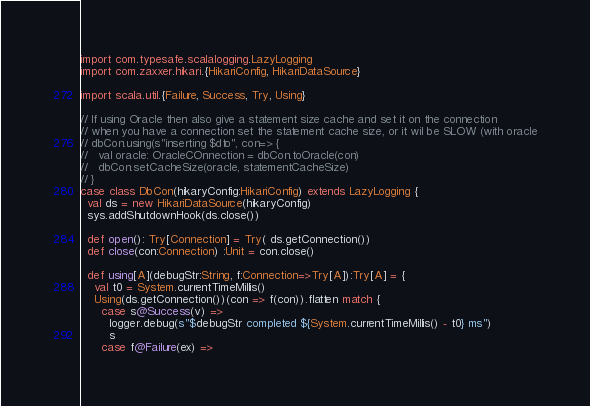Convert code to text. <code><loc_0><loc_0><loc_500><loc_500><_Scala_>import com.typesafe.scalalogging.LazyLogging
import com.zaxxer.hikari.{HikariConfig, HikariDataSource}

import scala.util.{Failure, Success, Try, Using}

// If using Oracle then also give a statement size cache and set it on the connection
// when you have a connection set the statement cache size, or it wil be SLOW (with oracle
// dbCon.using(s"inserting $dto", con=> {
//   val oracle: OracleCOnnection = dbCon.toOracle(con)
//   dbCon.setCacheSize(oracle, statementCacheSize)
// }
case class DbCon(hikaryConfig:HikariConfig) extends LazyLogging {
  val ds = new HikariDataSource(hikaryConfig)
  sys.addShutdownHook(ds.close())

  def open(): Try[Connection] = Try( ds.getConnection())
  def close(con:Connection) :Unit = con.close()

  def using[A](debugStr:String, f:Connection=>Try[A]):Try[A] = {
    val t0 = System.currentTimeMillis()
    Using(ds.getConnection())(con => f(con)).flatten match {
      case s@Success(v) =>
        logger.debug(s"$debugStr completed ${System.currentTimeMillis() - t0} ms")
        s
      case f@Failure(ex) =></code> 